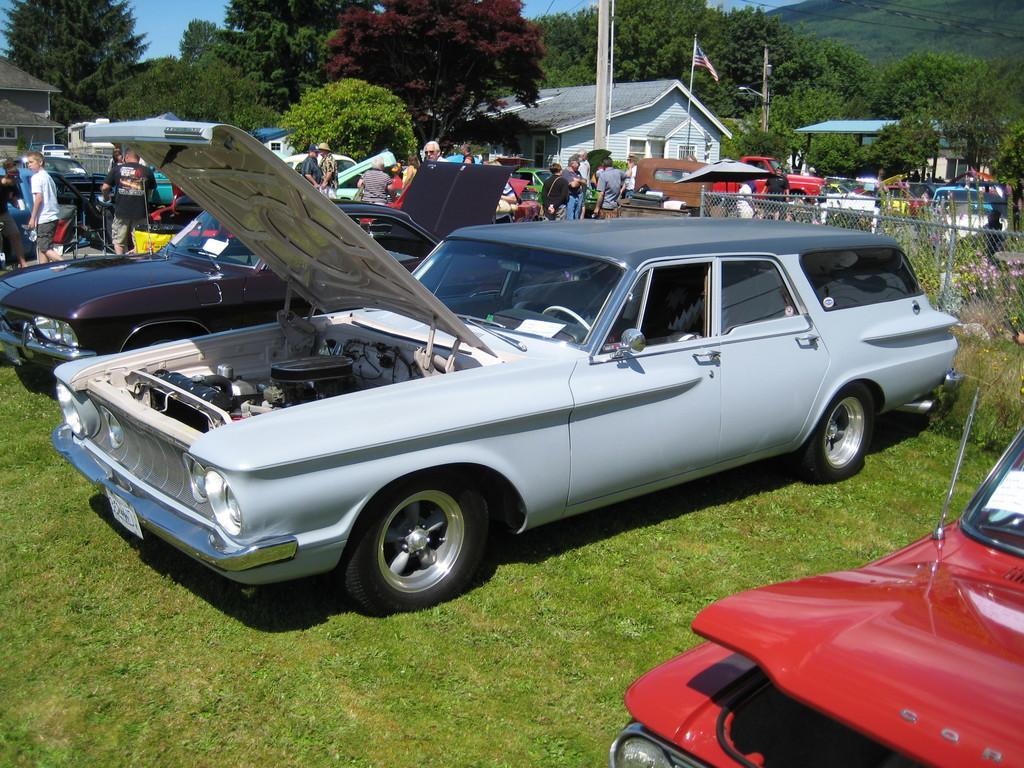Describe this image in one or two sentences. In this image, we can see persons and cars. There is a pole and flag in front of the shelter house. There is a fencing on the right side of the image. There is a grass on the ground. There are some trees at the top of the image. 